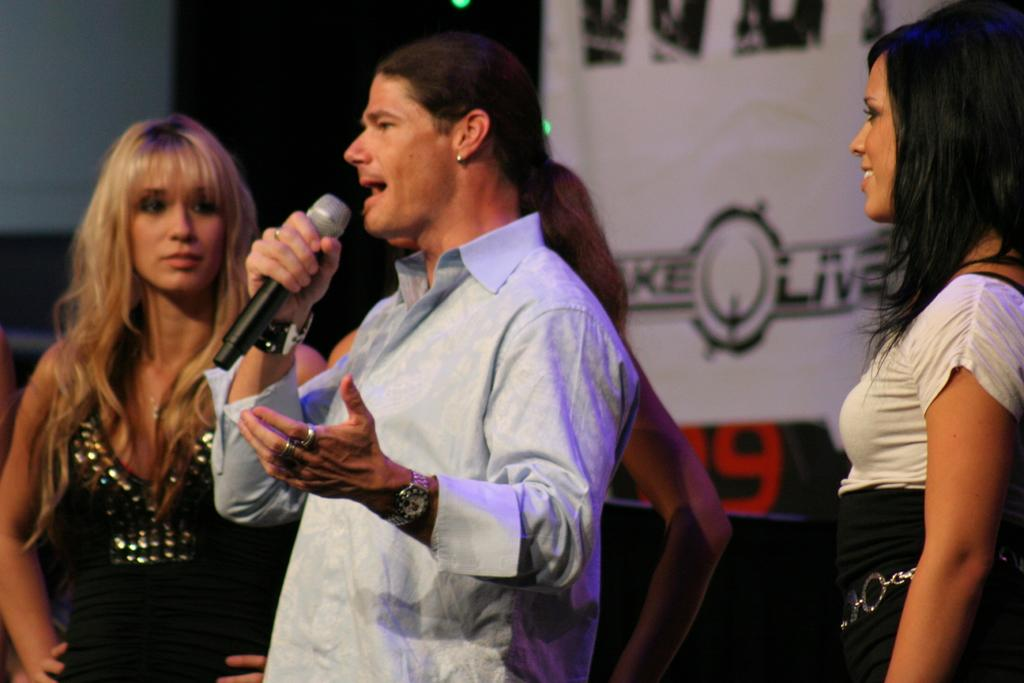What is the man in the image doing? The man is standing and talking into a microphone. Are there any other people in the image? Yes, there is a woman standing in the image, and another woman who is standing and smiling. What can be seen in the background of the image? There is a banner in the background of the image. What type of wrench is being used by the man in the image? There is no wrench present in the image; the man is talking into a microphone. How does the coal affect the scene in the image? There is no coal present in the image, so it cannot affect the scene. 